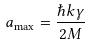<formula> <loc_0><loc_0><loc_500><loc_500>a _ { \max } = \frac { \hbar { k } \gamma } { 2 M }</formula> 